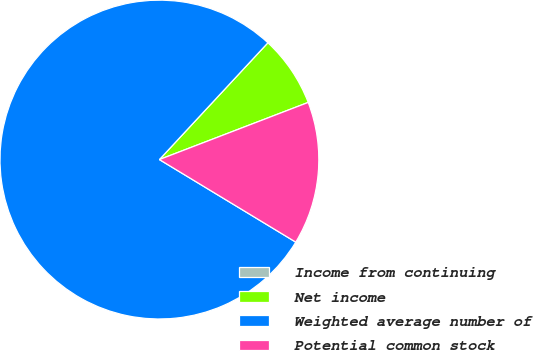Convert chart to OTSL. <chart><loc_0><loc_0><loc_500><loc_500><pie_chart><fcel>Income from continuing<fcel>Net income<fcel>Weighted average number of<fcel>Potential common stock<nl><fcel>0.0%<fcel>7.25%<fcel>78.25%<fcel>14.5%<nl></chart> 